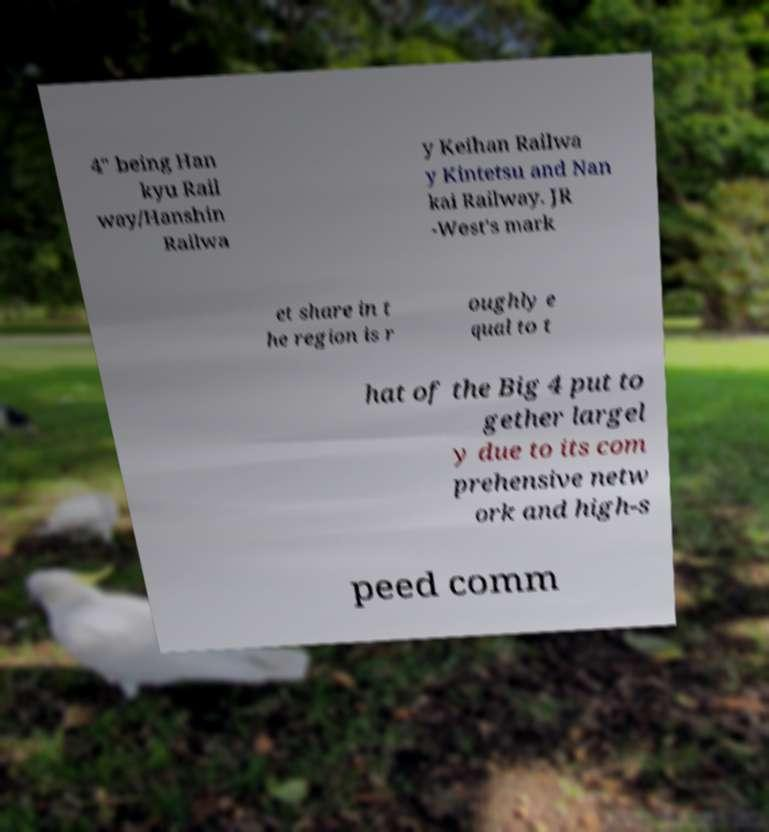Could you assist in decoding the text presented in this image and type it out clearly? 4" being Han kyu Rail way/Hanshin Railwa y Keihan Railwa y Kintetsu and Nan kai Railway. JR -West's mark et share in t he region is r oughly e qual to t hat of the Big 4 put to gether largel y due to its com prehensive netw ork and high-s peed comm 